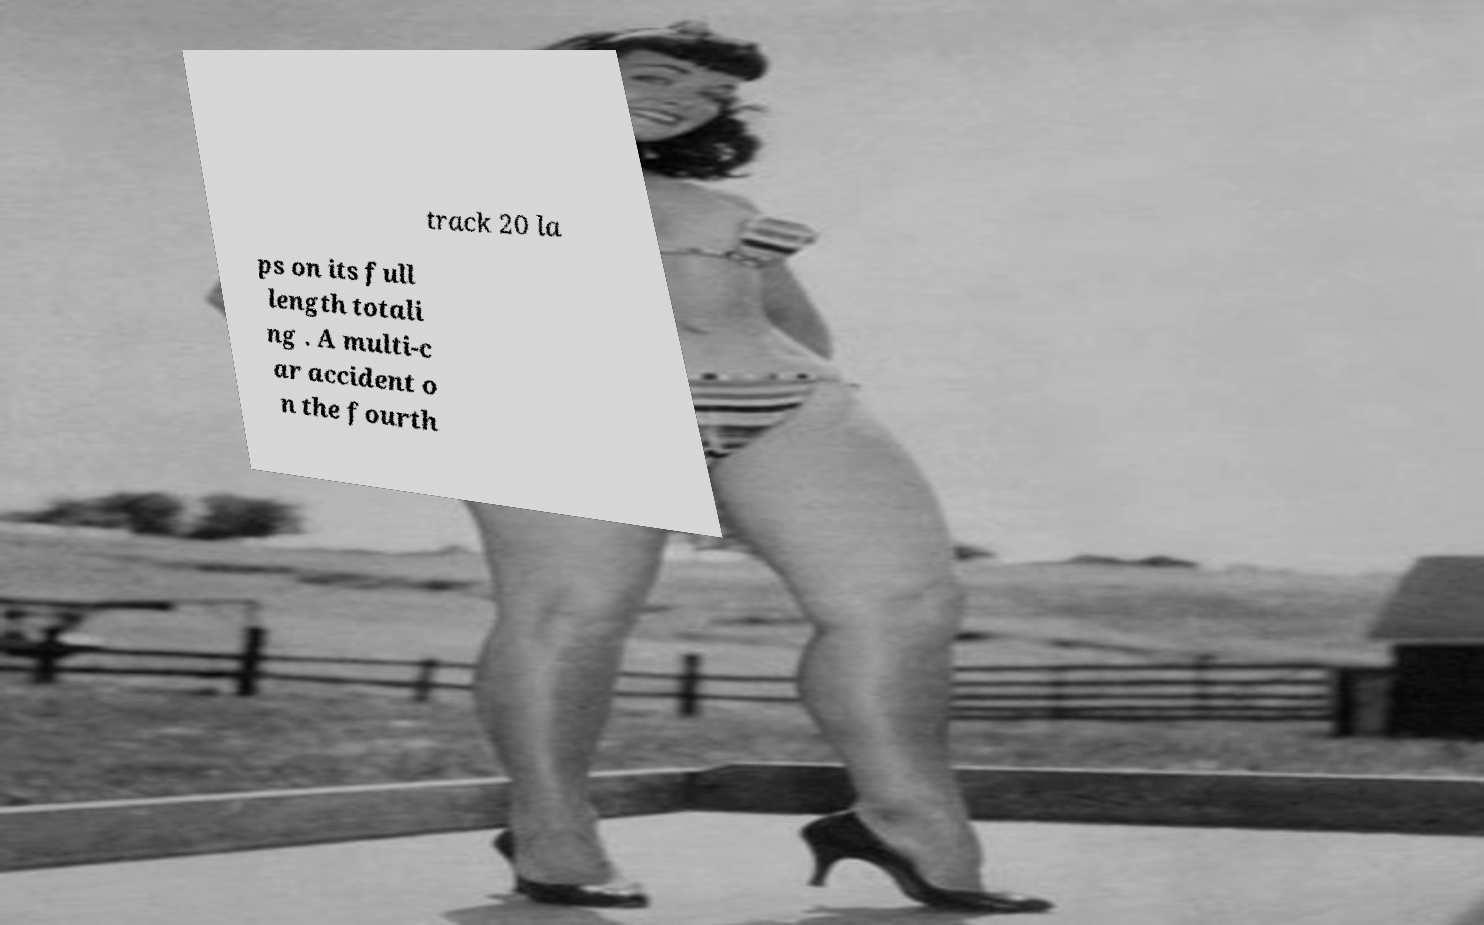Can you read and provide the text displayed in the image?This photo seems to have some interesting text. Can you extract and type it out for me? track 20 la ps on its full length totali ng . A multi-c ar accident o n the fourth 